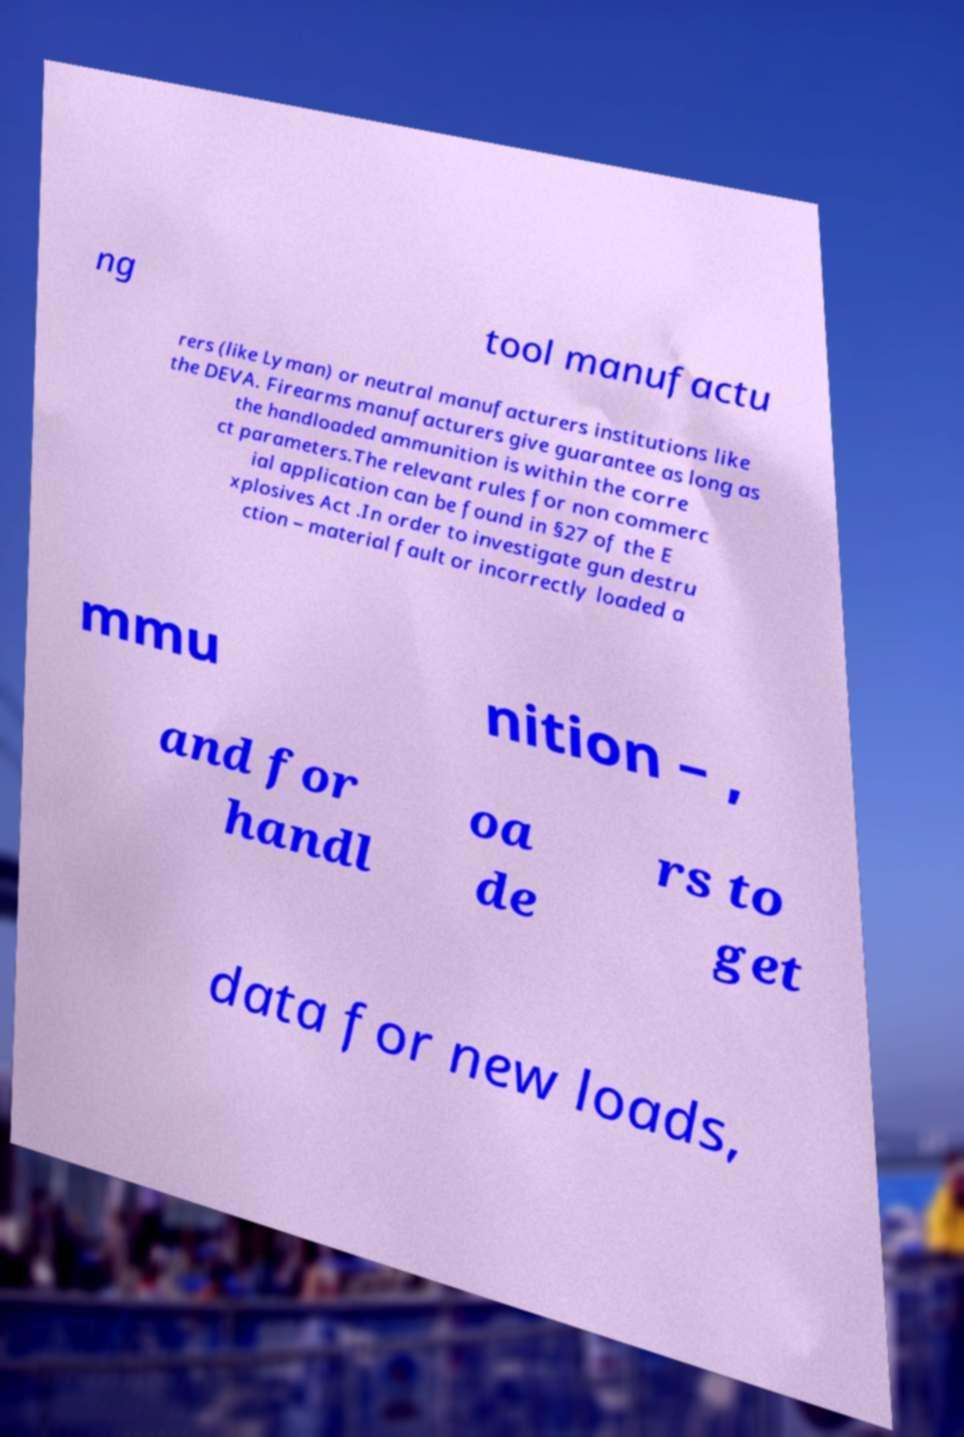For documentation purposes, I need the text within this image transcribed. Could you provide that? ng tool manufactu rers (like Lyman) or neutral manufacturers institutions like the DEVA. Firearms manufacturers give guarantee as long as the handloaded ammunition is within the corre ct parameters.The relevant rules for non commerc ial application can be found in §27 of the E xplosives Act .In order to investigate gun destru ction – material fault or incorrectly loaded a mmu nition – , and for handl oa de rs to get data for new loads, 